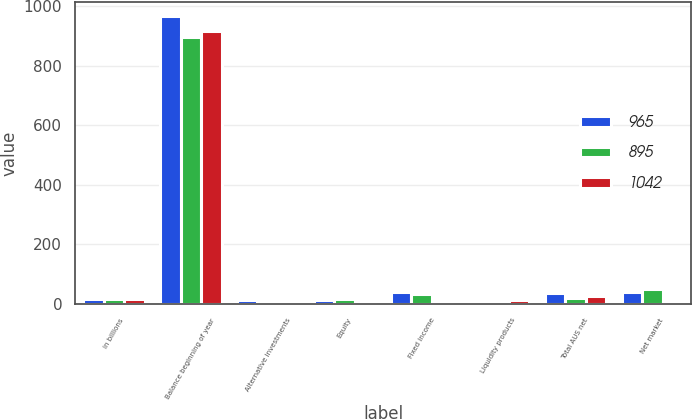Convert chart. <chart><loc_0><loc_0><loc_500><loc_500><stacked_bar_chart><ecel><fcel>in billions<fcel>Balance beginning of year<fcel>Alternative investments<fcel>Equity<fcel>Fixed income<fcel>Liquidity products<fcel>Total AUS net<fcel>Net market<nl><fcel>965<fcel>17<fcel>965<fcel>13<fcel>13<fcel>41<fcel>4<fcel>37<fcel>40<nl><fcel>895<fcel>17<fcel>895<fcel>1<fcel>17<fcel>34<fcel>3<fcel>21<fcel>49<nl><fcel>1042<fcel>17<fcel>917<fcel>1<fcel>5<fcel>9<fcel>12<fcel>27<fcel>5<nl></chart> 